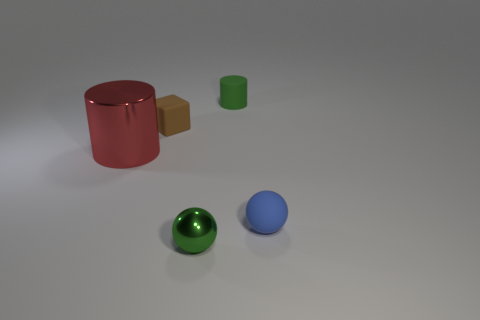Is the material of the tiny brown cube the same as the sphere that is behind the tiny green shiny object?
Your answer should be very brief. Yes. What number of other objects are there of the same shape as the brown object?
Offer a terse response. 0. Does the small matte cylinder have the same color as the shiny object that is behind the blue matte ball?
Keep it short and to the point. No. Is there anything else that has the same material as the large red object?
Keep it short and to the point. Yes. There is a thing that is to the left of the tiny thing that is to the left of the green sphere; what is its shape?
Provide a succinct answer. Cylinder. There is a shiny object that is the same color as the tiny cylinder; what size is it?
Give a very brief answer. Small. There is a matte object in front of the big metallic object; does it have the same shape as the tiny brown thing?
Offer a very short reply. No. Is the number of small green shiny things to the left of the tiny brown matte block greater than the number of green matte cylinders behind the large red object?
Your answer should be compact. No. There is a tiny green object behind the tiny blue rubber object; what number of green matte cylinders are left of it?
Make the answer very short. 0. There is a small cylinder that is the same color as the small shiny thing; what is its material?
Keep it short and to the point. Rubber. 